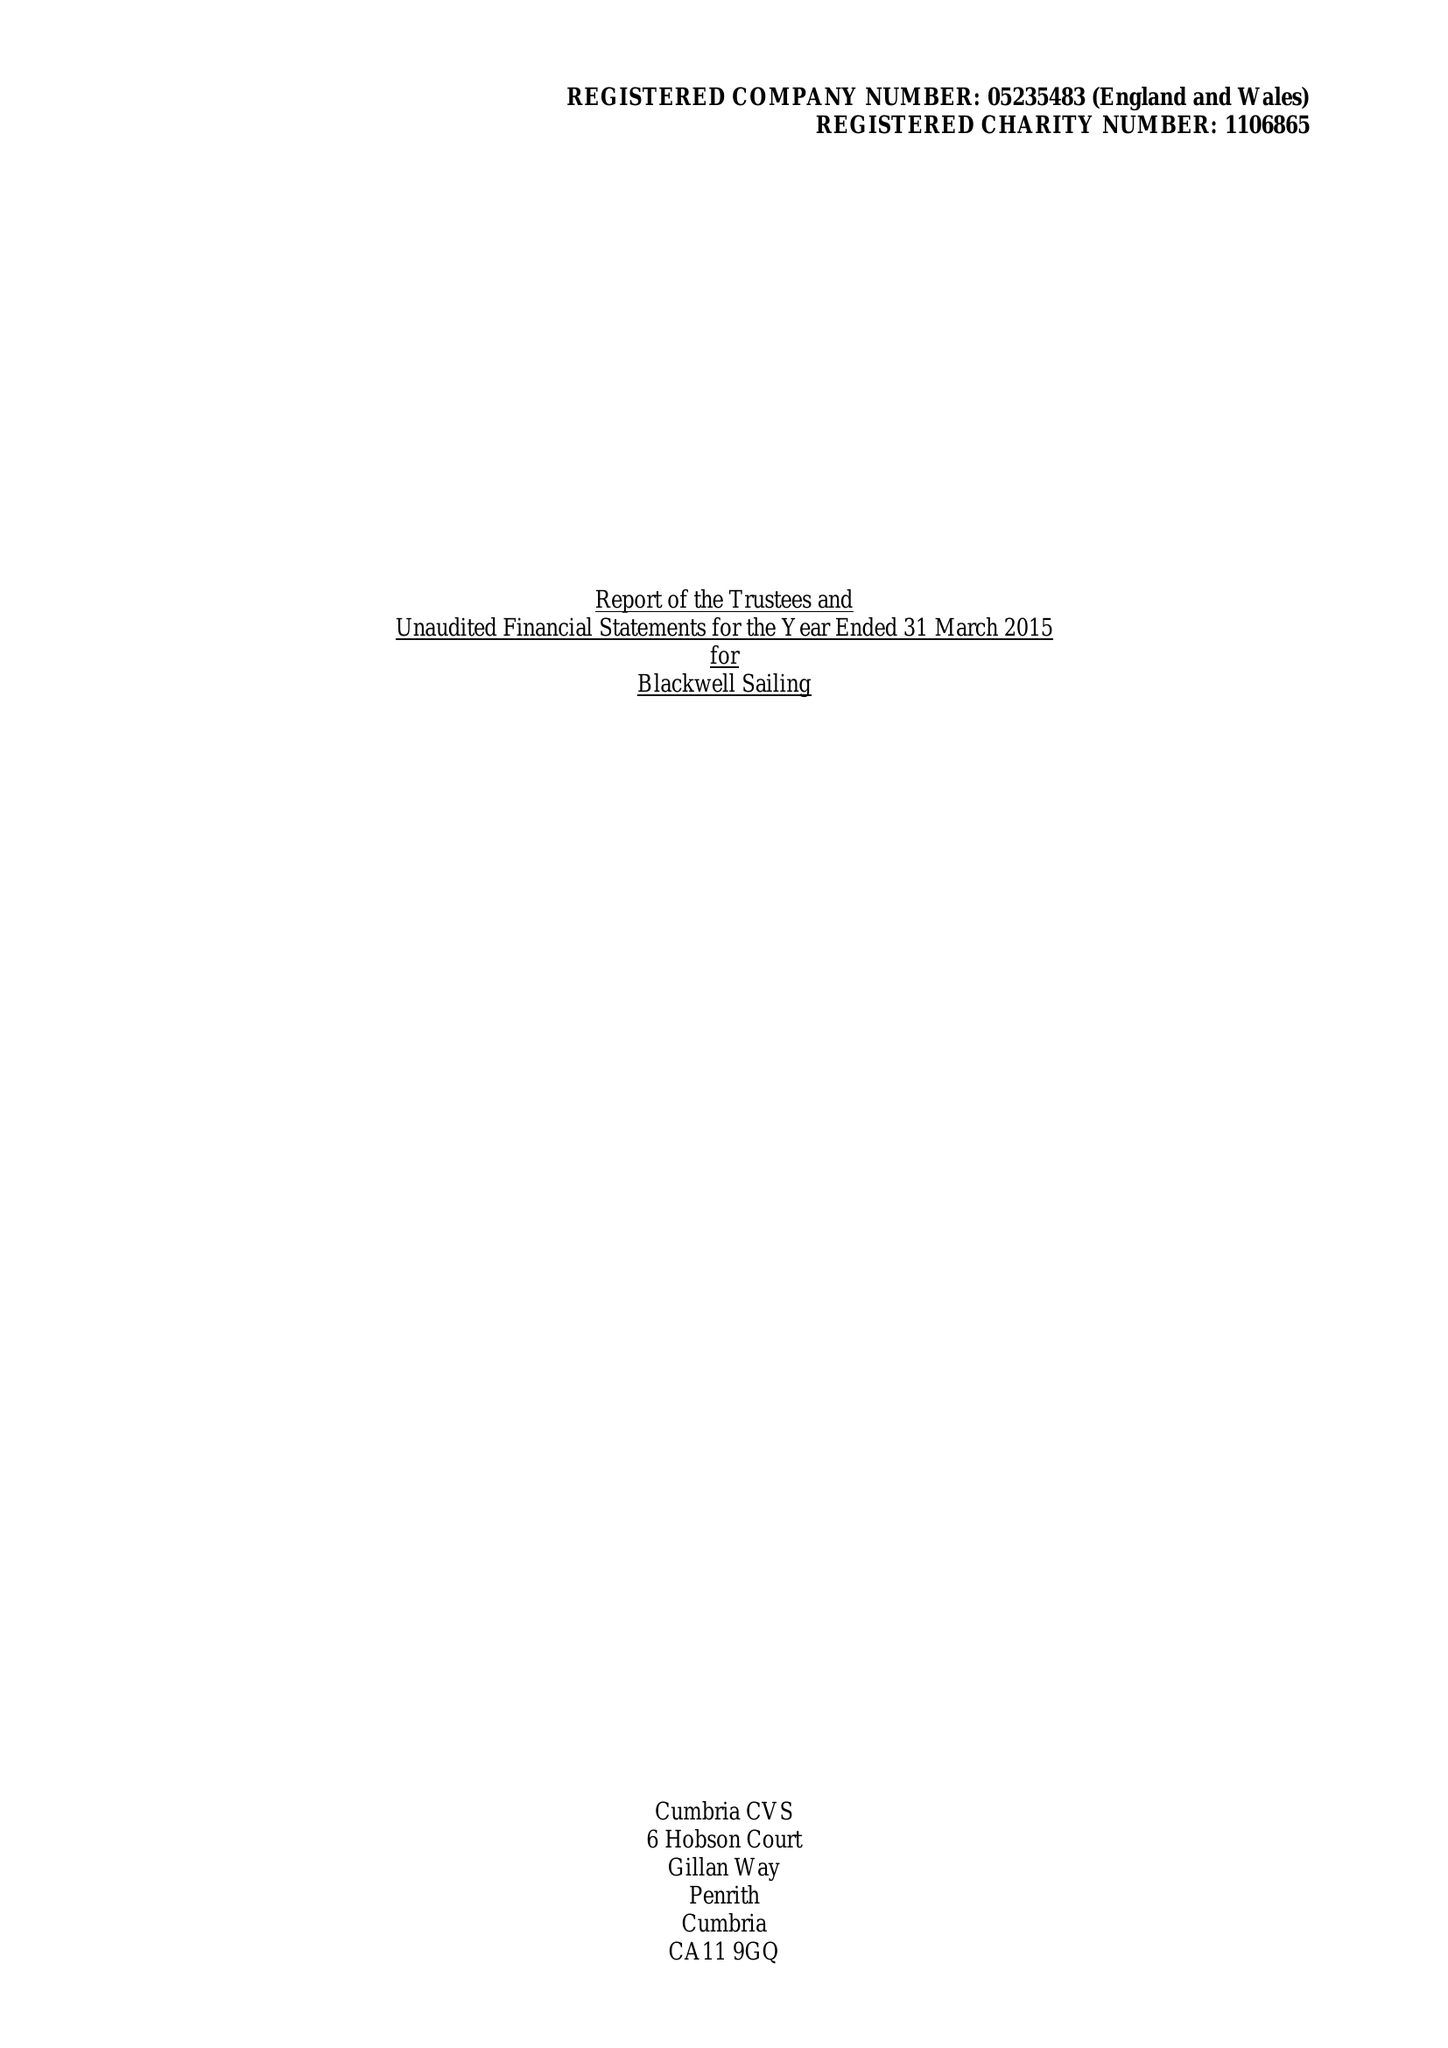What is the value for the charity_number?
Answer the question using a single word or phrase. 1106865 